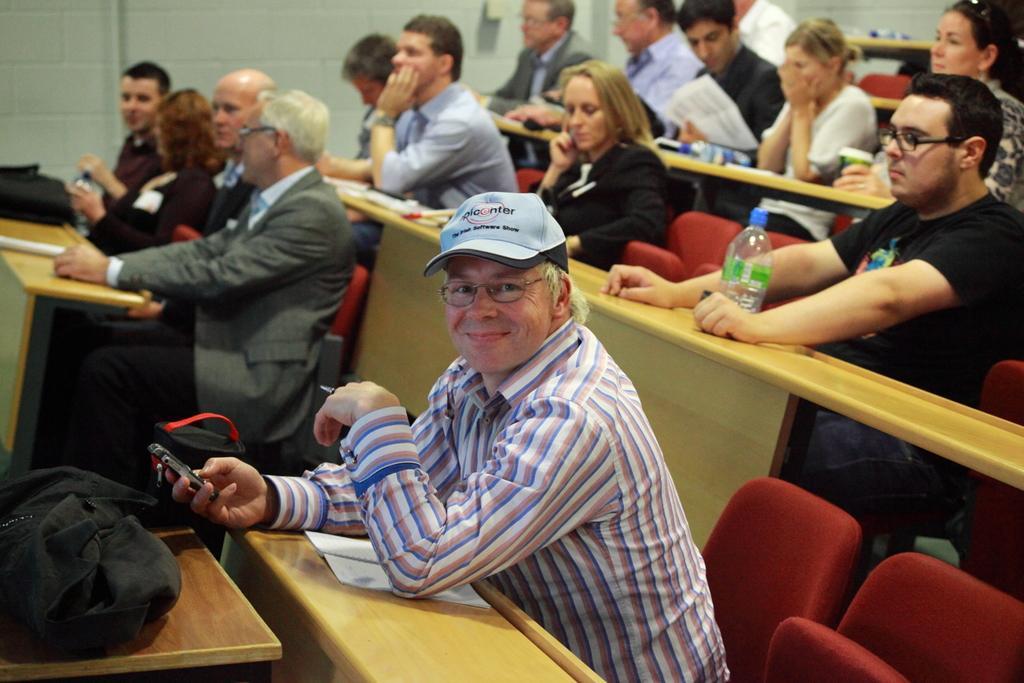Describe this image in one or two sentences. The picture is taken inside a room where number of people are sitting on the chairs in front of their desks and on right corner of the picture there is a person in black t-shirt wearing glasses and a bottle in front of him and in the left corner of the picture a person is wearing cap and a mobile in his hand and a bag in front of him and in the left corner of the picture there is one man in brown shirt in front of him there is a bag. 